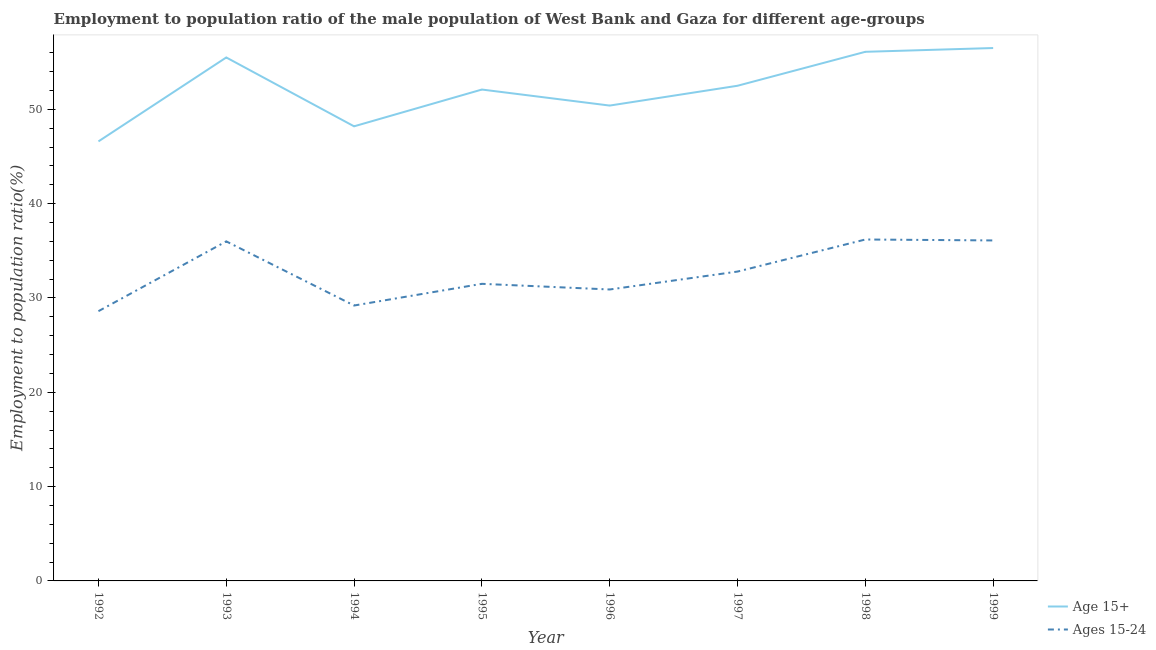How many different coloured lines are there?
Provide a short and direct response. 2. What is the employment to population ratio(age 15-24) in 1999?
Provide a short and direct response. 36.1. Across all years, what is the maximum employment to population ratio(age 15-24)?
Offer a terse response. 36.2. Across all years, what is the minimum employment to population ratio(age 15+)?
Offer a terse response. 46.6. In which year was the employment to population ratio(age 15+) minimum?
Your answer should be very brief. 1992. What is the total employment to population ratio(age 15-24) in the graph?
Make the answer very short. 261.3. What is the difference between the employment to population ratio(age 15-24) in 1995 and that in 1998?
Offer a terse response. -4.7. What is the difference between the employment to population ratio(age 15+) in 1996 and the employment to population ratio(age 15-24) in 1998?
Give a very brief answer. 14.2. What is the average employment to population ratio(age 15-24) per year?
Your answer should be very brief. 32.66. In the year 1996, what is the difference between the employment to population ratio(age 15+) and employment to population ratio(age 15-24)?
Your answer should be very brief. 19.5. What is the ratio of the employment to population ratio(age 15-24) in 1998 to that in 1999?
Your answer should be very brief. 1. Is the employment to population ratio(age 15-24) in 1993 less than that in 1997?
Your response must be concise. No. Is the difference between the employment to population ratio(age 15+) in 1998 and 1999 greater than the difference between the employment to population ratio(age 15-24) in 1998 and 1999?
Provide a short and direct response. No. What is the difference between the highest and the second highest employment to population ratio(age 15+)?
Your response must be concise. 0.4. What is the difference between the highest and the lowest employment to population ratio(age 15+)?
Your answer should be compact. 9.9. Is the sum of the employment to population ratio(age 15+) in 1992 and 1994 greater than the maximum employment to population ratio(age 15-24) across all years?
Your response must be concise. Yes. Does the employment to population ratio(age 15-24) monotonically increase over the years?
Make the answer very short. No. What is the difference between two consecutive major ticks on the Y-axis?
Provide a succinct answer. 10. How many legend labels are there?
Your response must be concise. 2. How are the legend labels stacked?
Provide a succinct answer. Vertical. What is the title of the graph?
Offer a very short reply. Employment to population ratio of the male population of West Bank and Gaza for different age-groups. Does "Education" appear as one of the legend labels in the graph?
Keep it short and to the point. No. What is the Employment to population ratio(%) of Age 15+ in 1992?
Give a very brief answer. 46.6. What is the Employment to population ratio(%) of Ages 15-24 in 1992?
Give a very brief answer. 28.6. What is the Employment to population ratio(%) in Age 15+ in 1993?
Provide a succinct answer. 55.5. What is the Employment to population ratio(%) in Ages 15-24 in 1993?
Your response must be concise. 36. What is the Employment to population ratio(%) of Age 15+ in 1994?
Give a very brief answer. 48.2. What is the Employment to population ratio(%) in Ages 15-24 in 1994?
Ensure brevity in your answer.  29.2. What is the Employment to population ratio(%) in Age 15+ in 1995?
Provide a short and direct response. 52.1. What is the Employment to population ratio(%) in Ages 15-24 in 1995?
Your answer should be compact. 31.5. What is the Employment to population ratio(%) in Age 15+ in 1996?
Offer a very short reply. 50.4. What is the Employment to population ratio(%) of Ages 15-24 in 1996?
Make the answer very short. 30.9. What is the Employment to population ratio(%) of Age 15+ in 1997?
Your response must be concise. 52.5. What is the Employment to population ratio(%) in Ages 15-24 in 1997?
Offer a very short reply. 32.8. What is the Employment to population ratio(%) of Age 15+ in 1998?
Offer a very short reply. 56.1. What is the Employment to population ratio(%) in Ages 15-24 in 1998?
Keep it short and to the point. 36.2. What is the Employment to population ratio(%) of Age 15+ in 1999?
Provide a succinct answer. 56.5. What is the Employment to population ratio(%) of Ages 15-24 in 1999?
Offer a very short reply. 36.1. Across all years, what is the maximum Employment to population ratio(%) of Age 15+?
Your response must be concise. 56.5. Across all years, what is the maximum Employment to population ratio(%) of Ages 15-24?
Your answer should be compact. 36.2. Across all years, what is the minimum Employment to population ratio(%) in Age 15+?
Your response must be concise. 46.6. Across all years, what is the minimum Employment to population ratio(%) in Ages 15-24?
Make the answer very short. 28.6. What is the total Employment to population ratio(%) in Age 15+ in the graph?
Keep it short and to the point. 417.9. What is the total Employment to population ratio(%) in Ages 15-24 in the graph?
Offer a terse response. 261.3. What is the difference between the Employment to population ratio(%) in Age 15+ in 1992 and that in 1993?
Your answer should be compact. -8.9. What is the difference between the Employment to population ratio(%) in Age 15+ in 1992 and that in 1994?
Your response must be concise. -1.6. What is the difference between the Employment to population ratio(%) in Ages 15-24 in 1992 and that in 1994?
Offer a terse response. -0.6. What is the difference between the Employment to population ratio(%) in Age 15+ in 1992 and that in 1996?
Make the answer very short. -3.8. What is the difference between the Employment to population ratio(%) in Age 15+ in 1992 and that in 1998?
Give a very brief answer. -9.5. What is the difference between the Employment to population ratio(%) in Age 15+ in 1992 and that in 1999?
Offer a very short reply. -9.9. What is the difference between the Employment to population ratio(%) of Ages 15-24 in 1992 and that in 1999?
Ensure brevity in your answer.  -7.5. What is the difference between the Employment to population ratio(%) in Age 15+ in 1993 and that in 1994?
Give a very brief answer. 7.3. What is the difference between the Employment to population ratio(%) in Ages 15-24 in 1993 and that in 1995?
Your answer should be very brief. 4.5. What is the difference between the Employment to population ratio(%) of Ages 15-24 in 1993 and that in 1998?
Ensure brevity in your answer.  -0.2. What is the difference between the Employment to population ratio(%) in Age 15+ in 1994 and that in 1995?
Give a very brief answer. -3.9. What is the difference between the Employment to population ratio(%) in Ages 15-24 in 1994 and that in 1995?
Your answer should be compact. -2.3. What is the difference between the Employment to population ratio(%) of Age 15+ in 1994 and that in 1996?
Your answer should be very brief. -2.2. What is the difference between the Employment to population ratio(%) of Age 15+ in 1994 and that in 1997?
Keep it short and to the point. -4.3. What is the difference between the Employment to population ratio(%) of Ages 15-24 in 1994 and that in 1997?
Give a very brief answer. -3.6. What is the difference between the Employment to population ratio(%) in Age 15+ in 1994 and that in 1998?
Make the answer very short. -7.9. What is the difference between the Employment to population ratio(%) of Age 15+ in 1995 and that in 1996?
Your response must be concise. 1.7. What is the difference between the Employment to population ratio(%) of Ages 15-24 in 1995 and that in 1996?
Ensure brevity in your answer.  0.6. What is the difference between the Employment to population ratio(%) of Age 15+ in 1996 and that in 1997?
Provide a short and direct response. -2.1. What is the difference between the Employment to population ratio(%) in Age 15+ in 1996 and that in 1998?
Your response must be concise. -5.7. What is the difference between the Employment to population ratio(%) in Ages 15-24 in 1996 and that in 1998?
Your answer should be compact. -5.3. What is the difference between the Employment to population ratio(%) in Age 15+ in 1996 and that in 1999?
Ensure brevity in your answer.  -6.1. What is the difference between the Employment to population ratio(%) in Age 15+ in 1997 and that in 1998?
Offer a very short reply. -3.6. What is the difference between the Employment to population ratio(%) of Age 15+ in 1997 and that in 1999?
Offer a terse response. -4. What is the difference between the Employment to population ratio(%) of Ages 15-24 in 1997 and that in 1999?
Your answer should be compact. -3.3. What is the difference between the Employment to population ratio(%) in Age 15+ in 1998 and that in 1999?
Provide a succinct answer. -0.4. What is the difference between the Employment to population ratio(%) of Ages 15-24 in 1998 and that in 1999?
Your answer should be compact. 0.1. What is the difference between the Employment to population ratio(%) in Age 15+ in 1992 and the Employment to population ratio(%) in Ages 15-24 in 1995?
Your answer should be compact. 15.1. What is the difference between the Employment to population ratio(%) of Age 15+ in 1992 and the Employment to population ratio(%) of Ages 15-24 in 1996?
Your response must be concise. 15.7. What is the difference between the Employment to population ratio(%) in Age 15+ in 1992 and the Employment to population ratio(%) in Ages 15-24 in 1998?
Provide a short and direct response. 10.4. What is the difference between the Employment to population ratio(%) in Age 15+ in 1992 and the Employment to population ratio(%) in Ages 15-24 in 1999?
Provide a succinct answer. 10.5. What is the difference between the Employment to population ratio(%) of Age 15+ in 1993 and the Employment to population ratio(%) of Ages 15-24 in 1994?
Offer a terse response. 26.3. What is the difference between the Employment to population ratio(%) in Age 15+ in 1993 and the Employment to population ratio(%) in Ages 15-24 in 1995?
Give a very brief answer. 24. What is the difference between the Employment to population ratio(%) in Age 15+ in 1993 and the Employment to population ratio(%) in Ages 15-24 in 1996?
Offer a terse response. 24.6. What is the difference between the Employment to population ratio(%) in Age 15+ in 1993 and the Employment to population ratio(%) in Ages 15-24 in 1997?
Provide a short and direct response. 22.7. What is the difference between the Employment to population ratio(%) of Age 15+ in 1993 and the Employment to population ratio(%) of Ages 15-24 in 1998?
Provide a short and direct response. 19.3. What is the difference between the Employment to population ratio(%) in Age 15+ in 1993 and the Employment to population ratio(%) in Ages 15-24 in 1999?
Make the answer very short. 19.4. What is the difference between the Employment to population ratio(%) of Age 15+ in 1994 and the Employment to population ratio(%) of Ages 15-24 in 1995?
Offer a terse response. 16.7. What is the difference between the Employment to population ratio(%) of Age 15+ in 1994 and the Employment to population ratio(%) of Ages 15-24 in 1997?
Ensure brevity in your answer.  15.4. What is the difference between the Employment to population ratio(%) of Age 15+ in 1994 and the Employment to population ratio(%) of Ages 15-24 in 1998?
Your answer should be very brief. 12. What is the difference between the Employment to population ratio(%) of Age 15+ in 1994 and the Employment to population ratio(%) of Ages 15-24 in 1999?
Make the answer very short. 12.1. What is the difference between the Employment to population ratio(%) of Age 15+ in 1995 and the Employment to population ratio(%) of Ages 15-24 in 1996?
Your response must be concise. 21.2. What is the difference between the Employment to population ratio(%) of Age 15+ in 1995 and the Employment to population ratio(%) of Ages 15-24 in 1997?
Make the answer very short. 19.3. What is the difference between the Employment to population ratio(%) in Age 15+ in 1996 and the Employment to population ratio(%) in Ages 15-24 in 1998?
Provide a short and direct response. 14.2. What is the difference between the Employment to population ratio(%) in Age 15+ in 1996 and the Employment to population ratio(%) in Ages 15-24 in 1999?
Provide a succinct answer. 14.3. What is the difference between the Employment to population ratio(%) of Age 15+ in 1998 and the Employment to population ratio(%) of Ages 15-24 in 1999?
Your answer should be compact. 20. What is the average Employment to population ratio(%) in Age 15+ per year?
Ensure brevity in your answer.  52.24. What is the average Employment to population ratio(%) in Ages 15-24 per year?
Offer a terse response. 32.66. In the year 1992, what is the difference between the Employment to population ratio(%) of Age 15+ and Employment to population ratio(%) of Ages 15-24?
Provide a succinct answer. 18. In the year 1993, what is the difference between the Employment to population ratio(%) of Age 15+ and Employment to population ratio(%) of Ages 15-24?
Keep it short and to the point. 19.5. In the year 1994, what is the difference between the Employment to population ratio(%) of Age 15+ and Employment to population ratio(%) of Ages 15-24?
Give a very brief answer. 19. In the year 1995, what is the difference between the Employment to population ratio(%) in Age 15+ and Employment to population ratio(%) in Ages 15-24?
Your answer should be very brief. 20.6. In the year 1996, what is the difference between the Employment to population ratio(%) in Age 15+ and Employment to population ratio(%) in Ages 15-24?
Your answer should be compact. 19.5. In the year 1998, what is the difference between the Employment to population ratio(%) in Age 15+ and Employment to population ratio(%) in Ages 15-24?
Your answer should be very brief. 19.9. In the year 1999, what is the difference between the Employment to population ratio(%) in Age 15+ and Employment to population ratio(%) in Ages 15-24?
Your response must be concise. 20.4. What is the ratio of the Employment to population ratio(%) in Age 15+ in 1992 to that in 1993?
Your answer should be compact. 0.84. What is the ratio of the Employment to population ratio(%) in Ages 15-24 in 1992 to that in 1993?
Give a very brief answer. 0.79. What is the ratio of the Employment to population ratio(%) in Age 15+ in 1992 to that in 1994?
Keep it short and to the point. 0.97. What is the ratio of the Employment to population ratio(%) of Ages 15-24 in 1992 to that in 1994?
Your answer should be compact. 0.98. What is the ratio of the Employment to population ratio(%) of Age 15+ in 1992 to that in 1995?
Offer a terse response. 0.89. What is the ratio of the Employment to population ratio(%) of Ages 15-24 in 1992 to that in 1995?
Offer a very short reply. 0.91. What is the ratio of the Employment to population ratio(%) of Age 15+ in 1992 to that in 1996?
Your response must be concise. 0.92. What is the ratio of the Employment to population ratio(%) of Ages 15-24 in 1992 to that in 1996?
Give a very brief answer. 0.93. What is the ratio of the Employment to population ratio(%) of Age 15+ in 1992 to that in 1997?
Provide a succinct answer. 0.89. What is the ratio of the Employment to population ratio(%) of Ages 15-24 in 1992 to that in 1997?
Keep it short and to the point. 0.87. What is the ratio of the Employment to population ratio(%) of Age 15+ in 1992 to that in 1998?
Your answer should be compact. 0.83. What is the ratio of the Employment to population ratio(%) of Ages 15-24 in 1992 to that in 1998?
Ensure brevity in your answer.  0.79. What is the ratio of the Employment to population ratio(%) of Age 15+ in 1992 to that in 1999?
Ensure brevity in your answer.  0.82. What is the ratio of the Employment to population ratio(%) of Ages 15-24 in 1992 to that in 1999?
Give a very brief answer. 0.79. What is the ratio of the Employment to population ratio(%) in Age 15+ in 1993 to that in 1994?
Offer a terse response. 1.15. What is the ratio of the Employment to population ratio(%) in Ages 15-24 in 1993 to that in 1994?
Offer a very short reply. 1.23. What is the ratio of the Employment to population ratio(%) in Age 15+ in 1993 to that in 1995?
Make the answer very short. 1.07. What is the ratio of the Employment to population ratio(%) in Age 15+ in 1993 to that in 1996?
Give a very brief answer. 1.1. What is the ratio of the Employment to population ratio(%) in Ages 15-24 in 1993 to that in 1996?
Your answer should be compact. 1.17. What is the ratio of the Employment to population ratio(%) of Age 15+ in 1993 to that in 1997?
Offer a very short reply. 1.06. What is the ratio of the Employment to population ratio(%) of Ages 15-24 in 1993 to that in 1997?
Make the answer very short. 1.1. What is the ratio of the Employment to population ratio(%) in Age 15+ in 1993 to that in 1998?
Offer a terse response. 0.99. What is the ratio of the Employment to population ratio(%) of Age 15+ in 1993 to that in 1999?
Your answer should be very brief. 0.98. What is the ratio of the Employment to population ratio(%) in Ages 15-24 in 1993 to that in 1999?
Offer a terse response. 1. What is the ratio of the Employment to population ratio(%) in Age 15+ in 1994 to that in 1995?
Your answer should be very brief. 0.93. What is the ratio of the Employment to population ratio(%) in Ages 15-24 in 1994 to that in 1995?
Offer a terse response. 0.93. What is the ratio of the Employment to population ratio(%) of Age 15+ in 1994 to that in 1996?
Give a very brief answer. 0.96. What is the ratio of the Employment to population ratio(%) in Ages 15-24 in 1994 to that in 1996?
Make the answer very short. 0.94. What is the ratio of the Employment to population ratio(%) in Age 15+ in 1994 to that in 1997?
Ensure brevity in your answer.  0.92. What is the ratio of the Employment to population ratio(%) of Ages 15-24 in 1994 to that in 1997?
Your response must be concise. 0.89. What is the ratio of the Employment to population ratio(%) in Age 15+ in 1994 to that in 1998?
Provide a short and direct response. 0.86. What is the ratio of the Employment to population ratio(%) in Ages 15-24 in 1994 to that in 1998?
Ensure brevity in your answer.  0.81. What is the ratio of the Employment to population ratio(%) of Age 15+ in 1994 to that in 1999?
Your response must be concise. 0.85. What is the ratio of the Employment to population ratio(%) of Ages 15-24 in 1994 to that in 1999?
Your response must be concise. 0.81. What is the ratio of the Employment to population ratio(%) in Age 15+ in 1995 to that in 1996?
Give a very brief answer. 1.03. What is the ratio of the Employment to population ratio(%) in Ages 15-24 in 1995 to that in 1996?
Your answer should be compact. 1.02. What is the ratio of the Employment to population ratio(%) in Age 15+ in 1995 to that in 1997?
Provide a short and direct response. 0.99. What is the ratio of the Employment to population ratio(%) in Ages 15-24 in 1995 to that in 1997?
Make the answer very short. 0.96. What is the ratio of the Employment to population ratio(%) of Age 15+ in 1995 to that in 1998?
Provide a succinct answer. 0.93. What is the ratio of the Employment to population ratio(%) in Ages 15-24 in 1995 to that in 1998?
Provide a short and direct response. 0.87. What is the ratio of the Employment to population ratio(%) of Age 15+ in 1995 to that in 1999?
Provide a short and direct response. 0.92. What is the ratio of the Employment to population ratio(%) in Ages 15-24 in 1995 to that in 1999?
Provide a short and direct response. 0.87. What is the ratio of the Employment to population ratio(%) of Ages 15-24 in 1996 to that in 1997?
Provide a succinct answer. 0.94. What is the ratio of the Employment to population ratio(%) in Age 15+ in 1996 to that in 1998?
Your response must be concise. 0.9. What is the ratio of the Employment to population ratio(%) of Ages 15-24 in 1996 to that in 1998?
Keep it short and to the point. 0.85. What is the ratio of the Employment to population ratio(%) of Age 15+ in 1996 to that in 1999?
Your answer should be very brief. 0.89. What is the ratio of the Employment to population ratio(%) in Ages 15-24 in 1996 to that in 1999?
Keep it short and to the point. 0.86. What is the ratio of the Employment to population ratio(%) of Age 15+ in 1997 to that in 1998?
Ensure brevity in your answer.  0.94. What is the ratio of the Employment to population ratio(%) in Ages 15-24 in 1997 to that in 1998?
Ensure brevity in your answer.  0.91. What is the ratio of the Employment to population ratio(%) in Age 15+ in 1997 to that in 1999?
Keep it short and to the point. 0.93. What is the ratio of the Employment to population ratio(%) in Ages 15-24 in 1997 to that in 1999?
Ensure brevity in your answer.  0.91. What is the ratio of the Employment to population ratio(%) in Ages 15-24 in 1998 to that in 1999?
Ensure brevity in your answer.  1. What is the difference between the highest and the second highest Employment to population ratio(%) in Ages 15-24?
Provide a succinct answer. 0.1. What is the difference between the highest and the lowest Employment to population ratio(%) of Age 15+?
Make the answer very short. 9.9. 